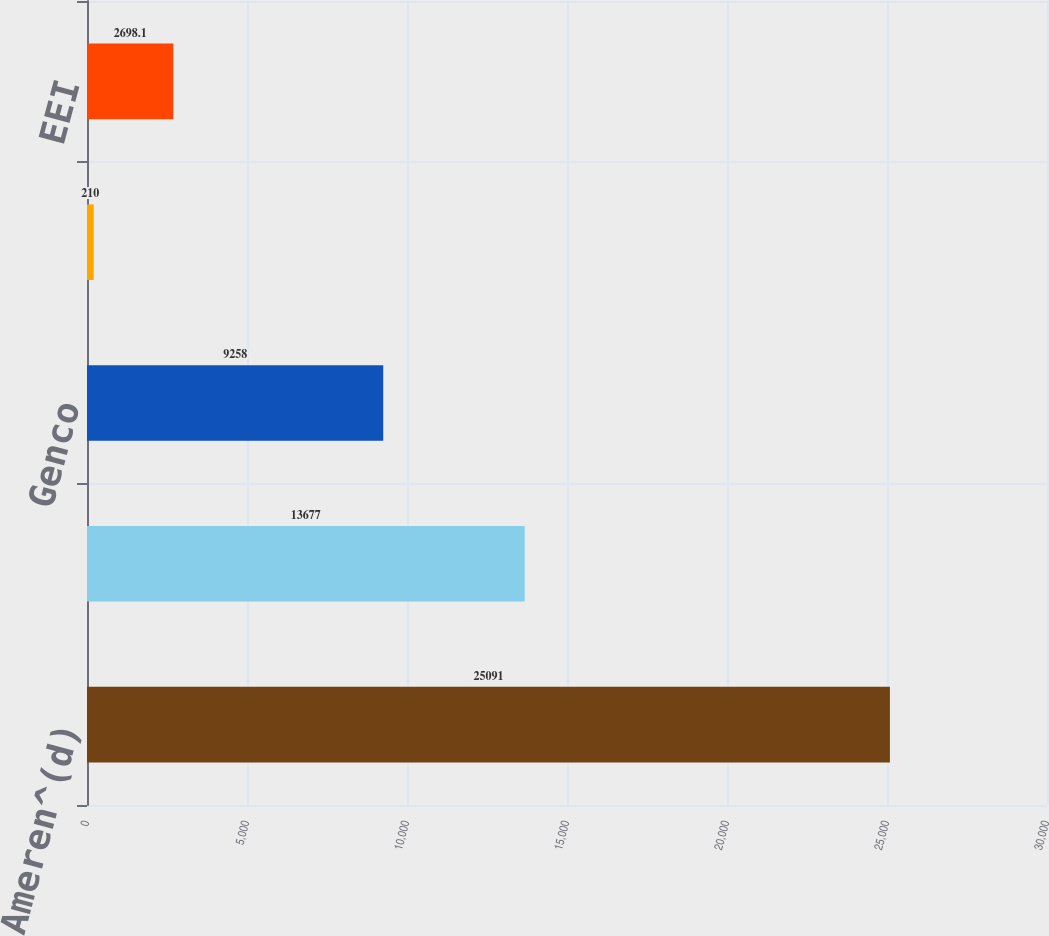Convert chart. <chart><loc_0><loc_0><loc_500><loc_500><bar_chart><fcel>Ameren^(d)<fcel>UE<fcel>Genco<fcel>CILCO (AERG)<fcel>EEI<nl><fcel>25091<fcel>13677<fcel>9258<fcel>210<fcel>2698.1<nl></chart> 